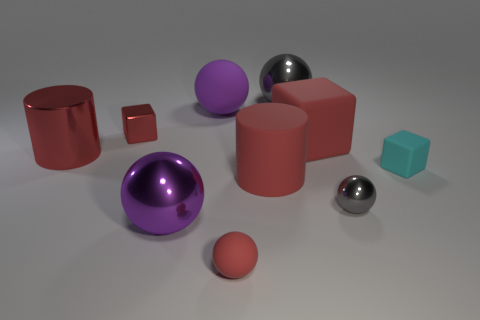What is the size of the red cube that is left of the sphere in front of the large purple metallic thing?
Your answer should be compact. Small. There is a large thing that is both left of the purple matte object and right of the tiny red block; what material is it made of?
Your response must be concise. Metal. What color is the big metal cylinder?
Keep it short and to the point. Red. There is a large rubber thing behind the red shiny cube; what is its shape?
Ensure brevity in your answer.  Sphere. Is there a large metal thing that is in front of the red block to the right of the small block that is left of the small red rubber sphere?
Keep it short and to the point. Yes. Are any small blue metallic spheres visible?
Your answer should be very brief. No. Is the material of the gray thing behind the small rubber cube the same as the small object right of the tiny gray metallic sphere?
Keep it short and to the point. No. There is a matte block that is in front of the red rubber thing that is to the right of the gray sphere that is behind the tiny red metal cube; what size is it?
Provide a succinct answer. Small. How many large blue blocks are made of the same material as the big gray object?
Give a very brief answer. 0. Are there fewer big red metallic cylinders than small shiny objects?
Your response must be concise. Yes. 